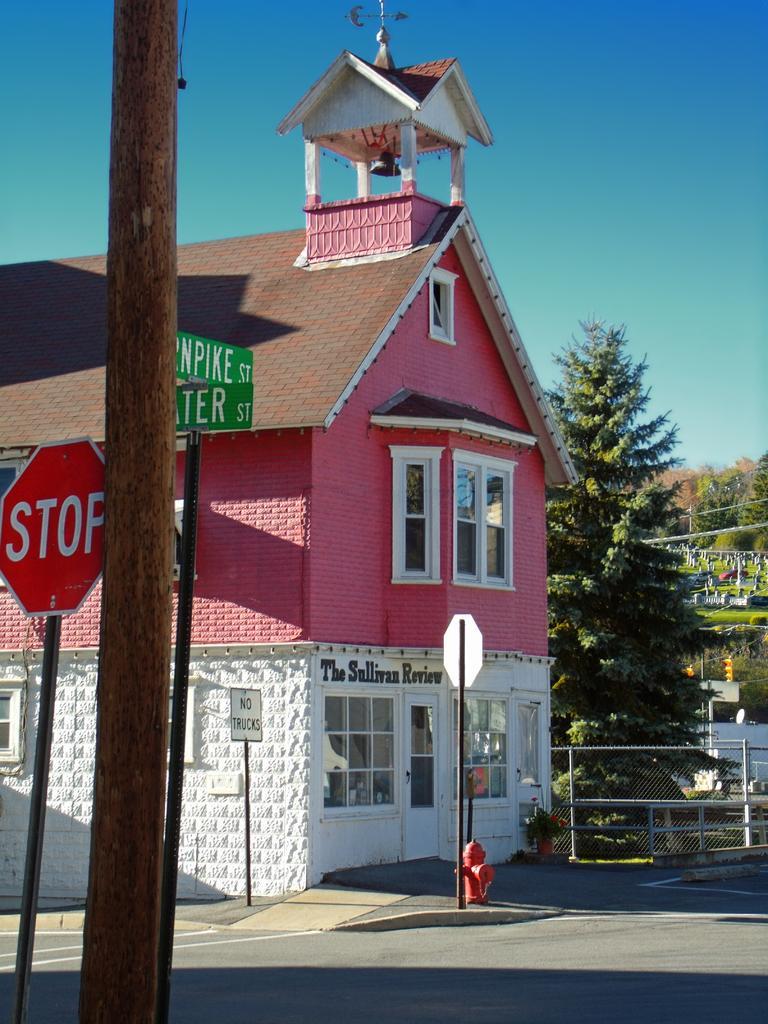Could you give a brief overview of what you see in this image? In the center of the image there is a house. To the left side of the image there is a pole. There are sign board. To the right side of the image there are trees. At the bottom of the image there is road. At the top of the image there is sky. 